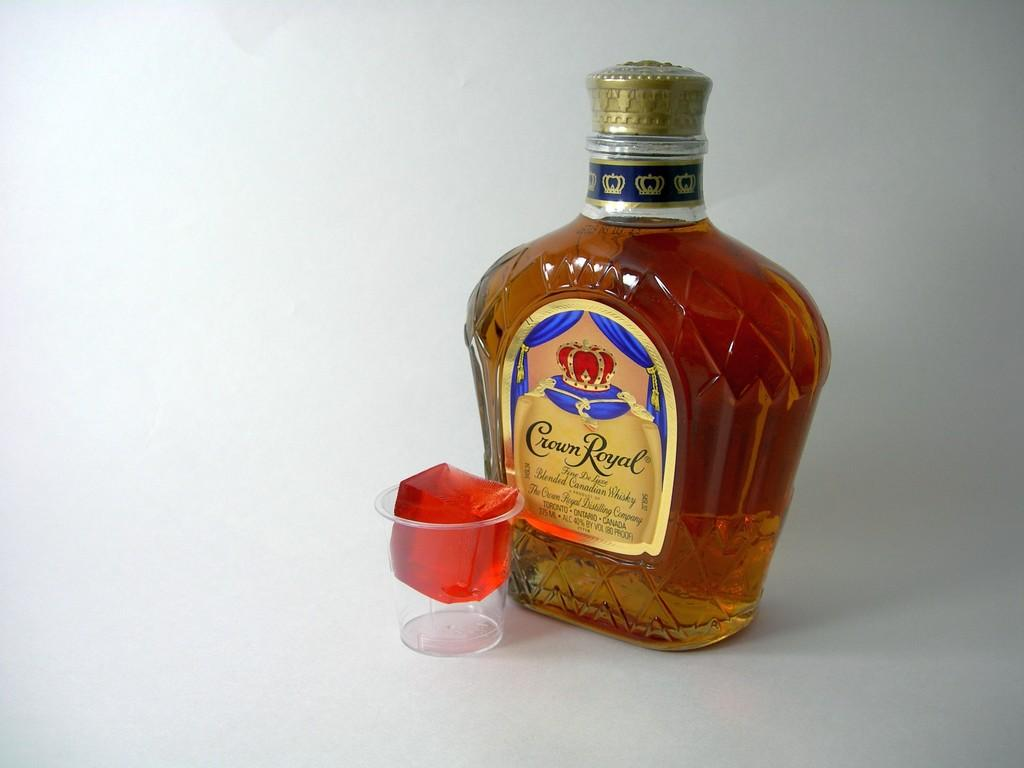Provide a one-sentence caption for the provided image. A bottle of Crown Royal whiskey next to a small plastic cup containing a red cube of gelatin. 